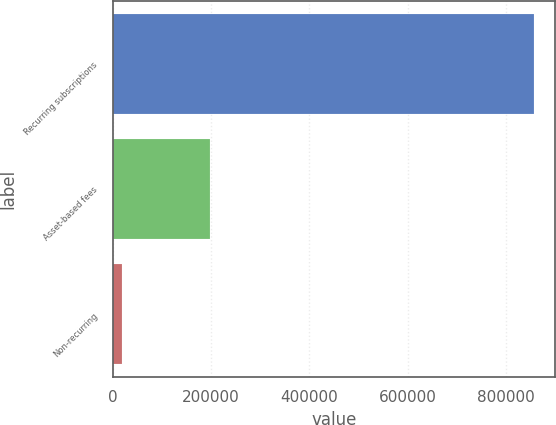<chart> <loc_0><loc_0><loc_500><loc_500><bar_chart><fcel>Recurring subscriptions<fcel>Asset-based fees<fcel>Non-recurring<nl><fcel>857527<fcel>197974<fcel>19512<nl></chart> 